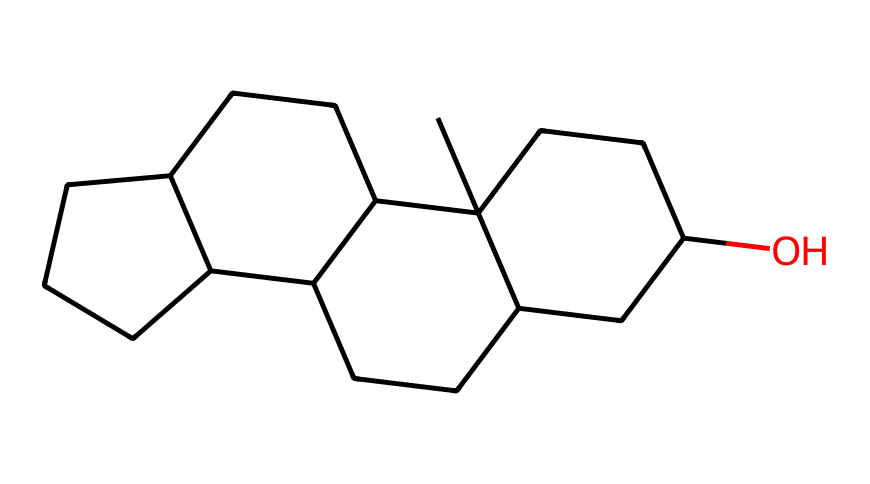What is the molecular formula of this compound? To determine the molecular formula, we need to identify the number and types of atoms present in the SMILES representation. The chemical consists of 27 carbon atoms and 46 hydrogen atoms. Therefore, the molecular formula is C27H46.
Answer: C27H46 How many rings are present in the structure? By examining the SMILES notation, we can identify the cycloalkane configuration. The number of cyclic structures (rings) can be counted, and in this case, there are four interconnected rings, which constitute the core of cholesterol.
Answer: four What is the functional group present in this compound? The structure reveals that there is a hydroxyl group (-OH) at one position, indicating that this compound is an alcohol. The presence of this functional group is crucial for the biological activity of cholesterol.
Answer: hydroxyl group What type of hydrocarbon is cholesterol classified as? Examining the structure, cholesterol has multiple carbon rings and cannot be classified as open-chain aliphatic hydrocarbons. Instead, it is categorized as a steroid, which is a specific type of cycloalkane with fused rings.
Answer: steroid Does cholesterol contain any double bonds in its structure? The standard structure of cholesterol as derived from its SMILES does not show any C=C double bonds, which are typically represented by alternating single and double links between carbon atoms. Therefore, cholesterol is fully saturated in this representation.
Answer: no What is the primary biological role of cholesterol in the body? Cholesterol serves as a building block for cell membranes and is a precursor for the synthesis of steroid hormones, vital for various physiological processes. Its structural form enables it to maintain membrane fluidity, which is crucial for cell function.
Answer: building block for cell membranes 